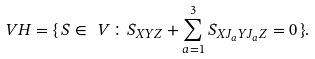<formula> <loc_0><loc_0><loc_500><loc_500>\ V H = \{ \, S \in \ V \colon S _ { X Y Z } + \sum _ { a = 1 } ^ { 3 } S _ { X J _ { a } Y J _ { a } Z } = 0 \, \} .</formula> 